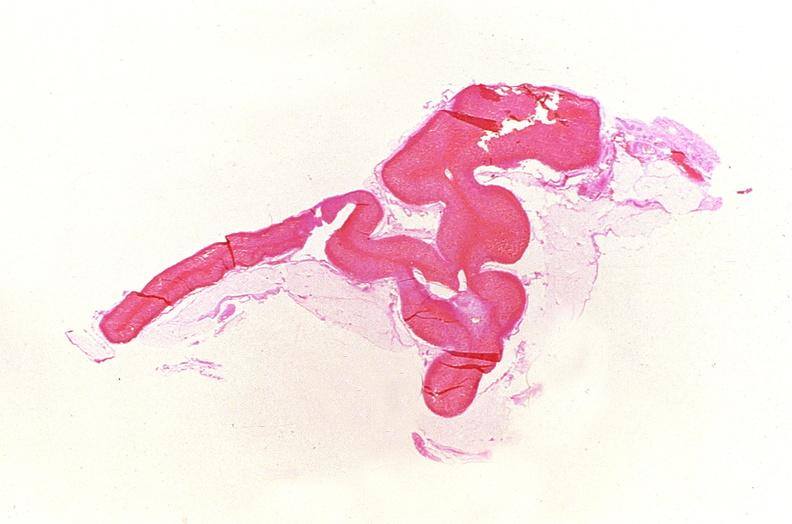what is present?
Answer the question using a single word or phrase. Endocrine 